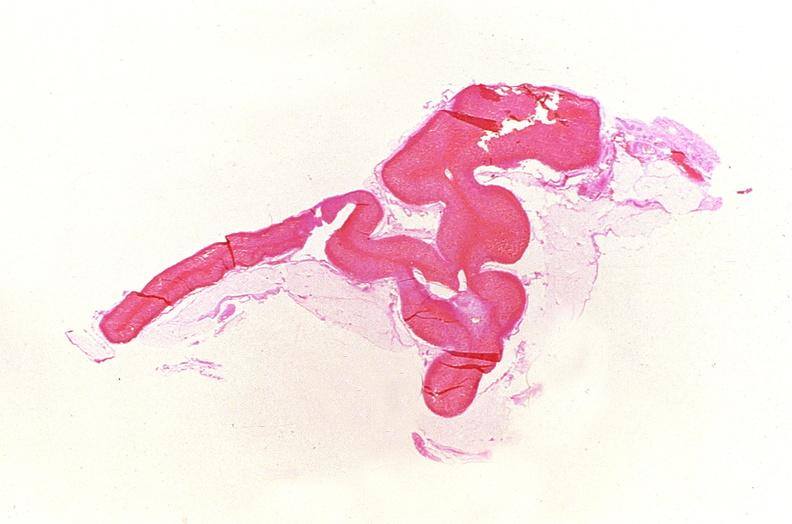what is present?
Answer the question using a single word or phrase. Endocrine 